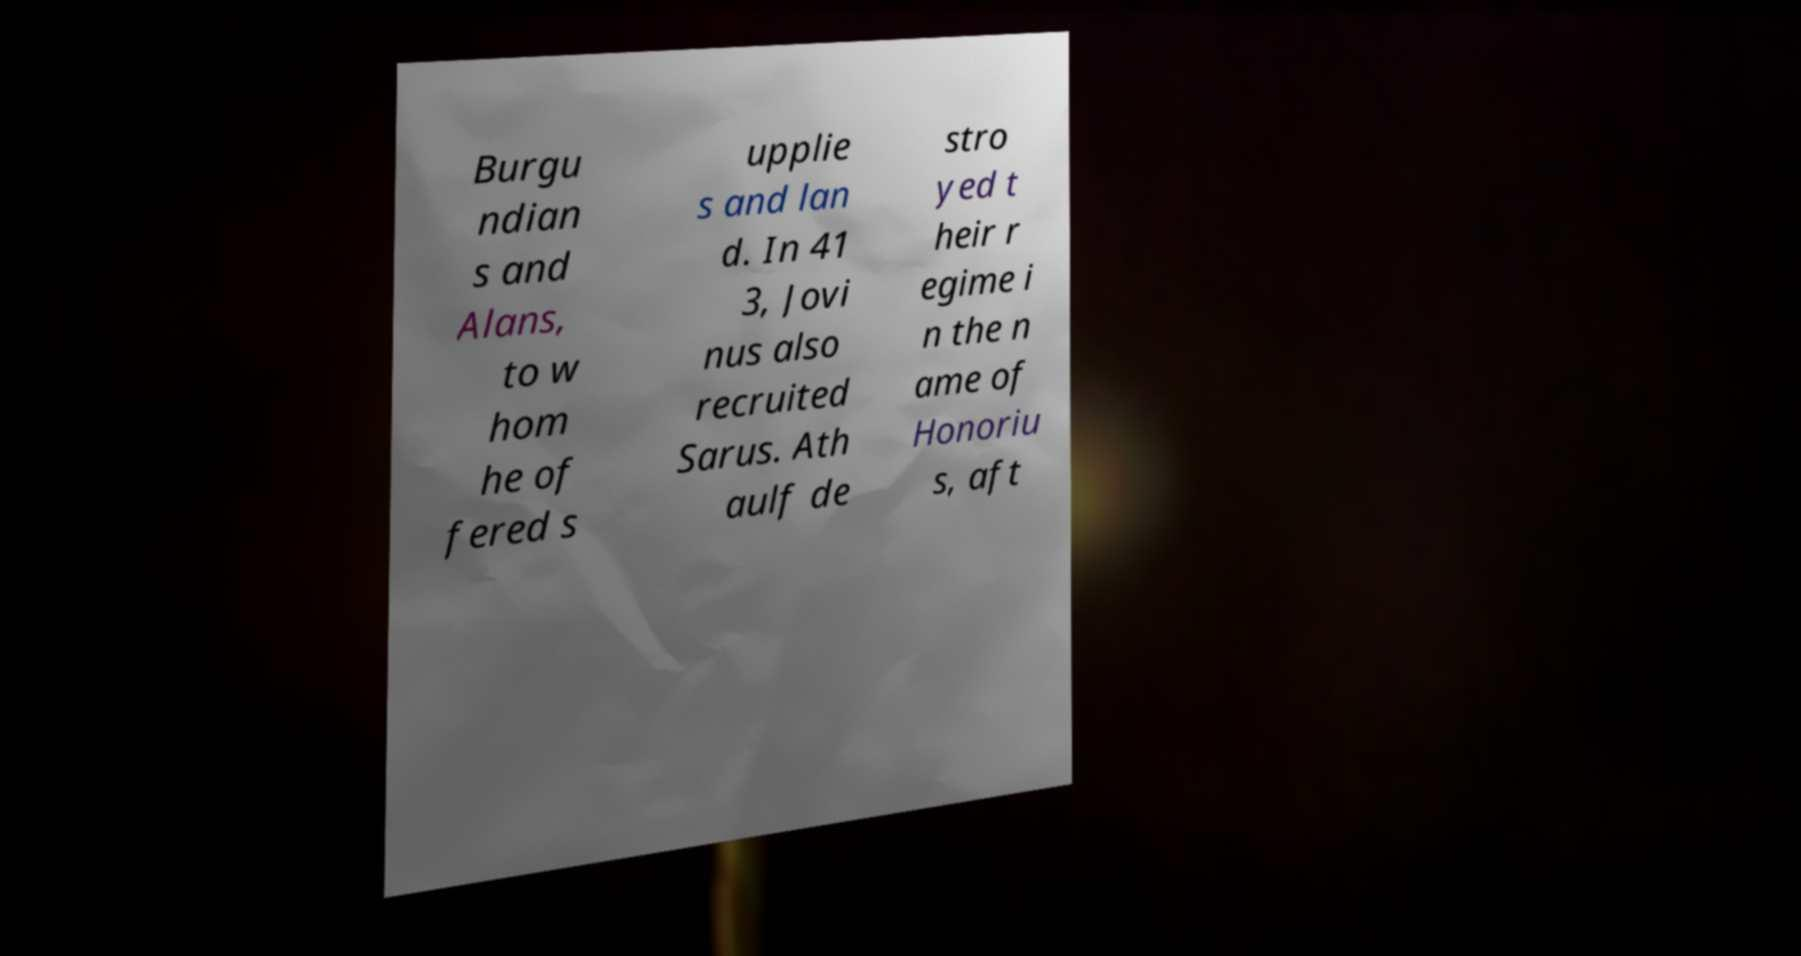Please identify and transcribe the text found in this image. Burgu ndian s and Alans, to w hom he of fered s upplie s and lan d. In 41 3, Jovi nus also recruited Sarus. Ath aulf de stro yed t heir r egime i n the n ame of Honoriu s, aft 